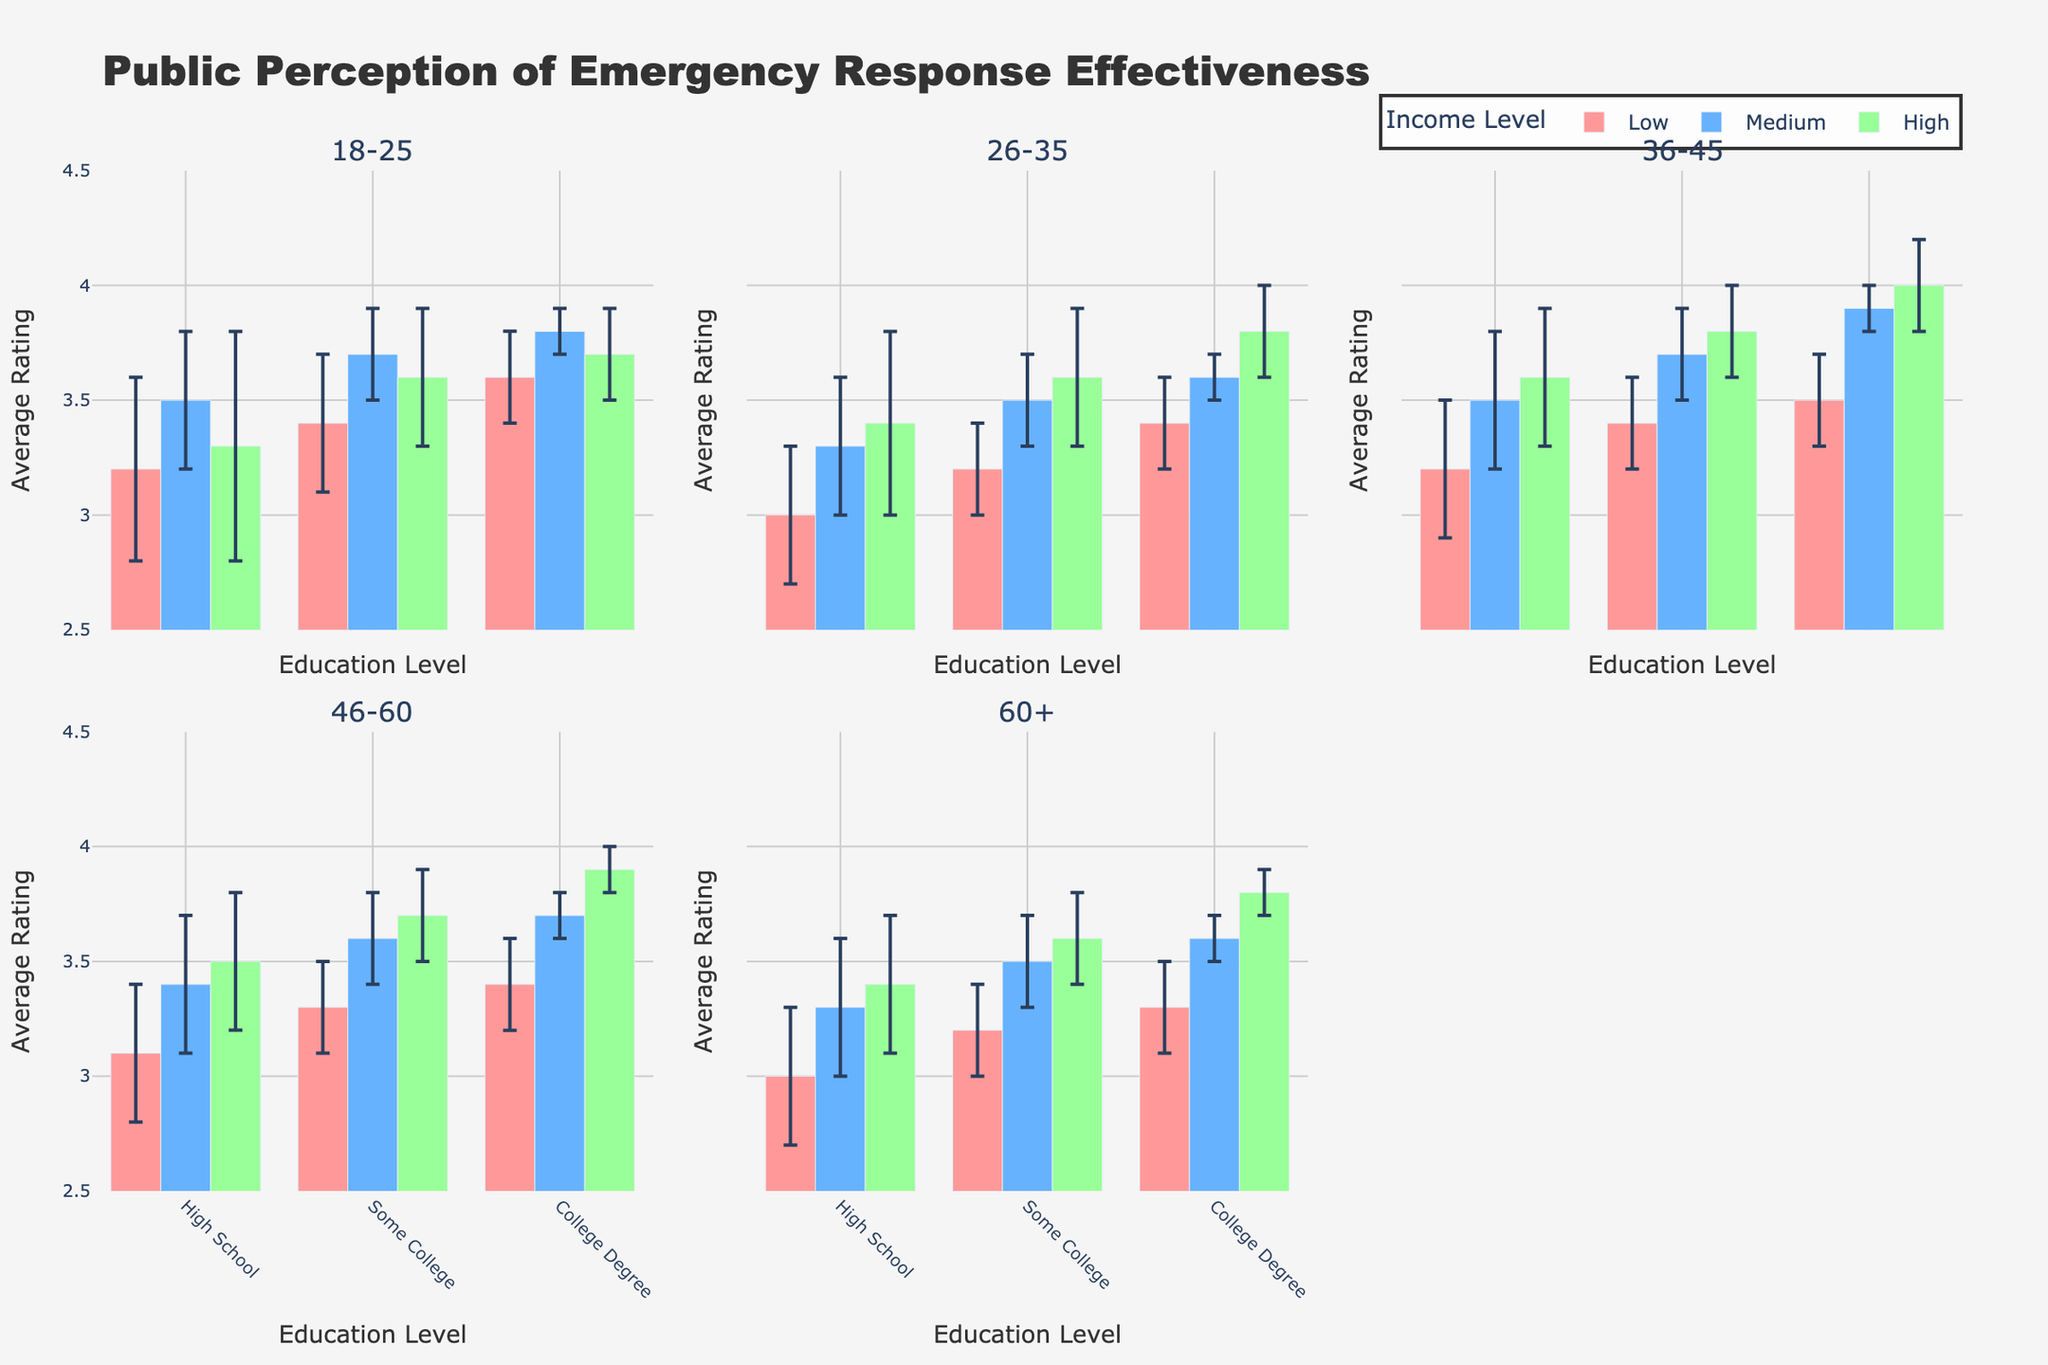What is the title of the figure? The title is displayed at the top of the figure and reads, "Public Perception of Emergency Response Effectiveness."
Answer: Public Perception of Emergency Response Effectiveness What does the y-axis represent? The y-axis represents the "Average Rating" which is the measure of public perception of emergency response effectiveness.
Answer: Average Rating What are the colors used for the income levels? The colors correspond to different income levels: Low (light red), Medium (light blue), and High (light green).
Answer: Light red, light blue, and light green Which age group has the highest average rating for a "High" income level and a "College Degree"? We look at the bars representing the "High" income level and "College Degree" across all age groups. The age group 36-45 has the highest rating of 4.0.
Answer: 36-45 Among the "18-25" age group, which income level shows the smallest error margin for "College Degree" education? We observe the error margins for "College Degree" in the "18-25" age group for Low, Medium, and High income levels. The Medium income level has the smallest error margin of 0.1.
Answer: Medium What is the average rating for the "60+" age group with "Some College" education at the Medium income level? From the figure, we find that the "60+" age group at Medium income level with "Some College" education has an average rating of 3.5.
Answer: 3.5 Which age group and income level combination has the largest error margin? We look for the combination of age group and income level with the largest error margin value. The "18-25" age group with High income level and High School education has the largest error margin of 0.5.
Answer: 18-25, High income, High School education For the "26-35" age group, compare the average ratings between income levels for "Some College" education. For the "26-35" age group with "Some College" education, the average ratings are: Low (3.2), Medium (3.5), and High (3.6). The High income level has the highest rating compared to Medium and Low.
Answer: High How does the average rating for "46-60" age group with "High School" education at Medium income level compare to that of "College Degree" at the same income level? For the "46-60" age group at Medium income level, the average rating for "High School" education is 3.4, whereas for "College Degree," it is 3.7. The rating is higher for "College Degree."
Answer: College Degree is higher What is the general trend observed for average ratings as education levels increase across all age groups? Generally, as the education level increases from High School to College Degree, the average ratings tend to increase as well across all age groups and income levels, indicating higher appreciation of emergency response effectiveness with higher education.
Answer: Increase with higher education 